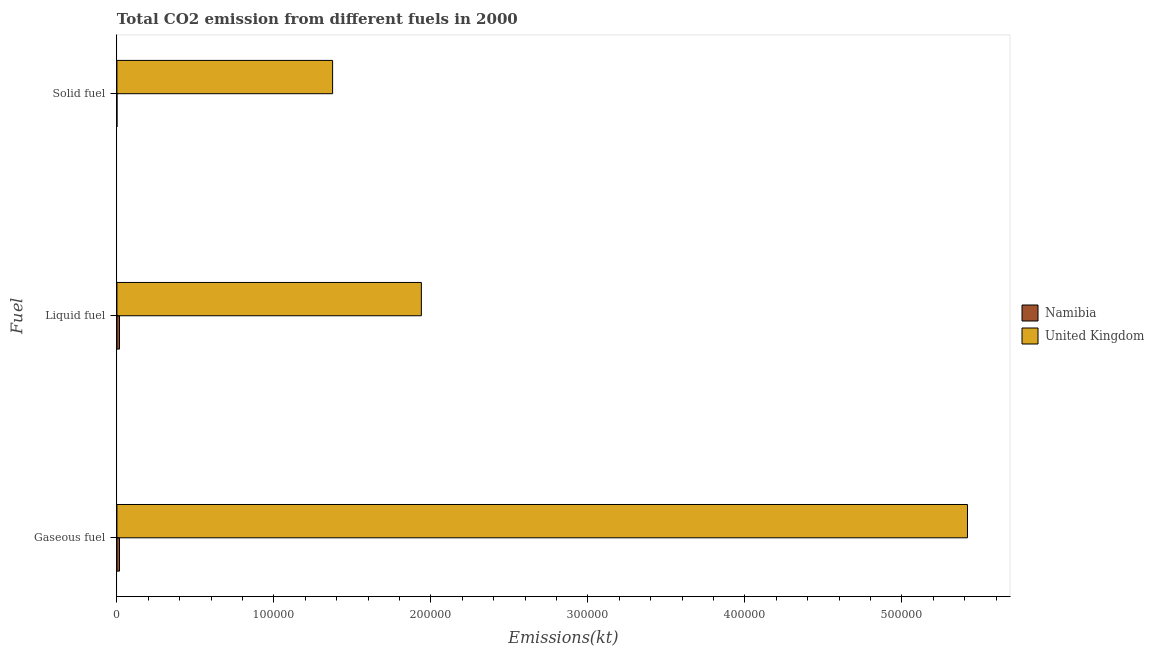How many groups of bars are there?
Your answer should be compact. 3. Are the number of bars on each tick of the Y-axis equal?
Provide a short and direct response. Yes. What is the label of the 2nd group of bars from the top?
Keep it short and to the point. Liquid fuel. What is the amount of co2 emissions from solid fuel in United Kingdom?
Your response must be concise. 1.37e+05. Across all countries, what is the maximum amount of co2 emissions from solid fuel?
Offer a terse response. 1.37e+05. Across all countries, what is the minimum amount of co2 emissions from solid fuel?
Make the answer very short. 7.33. In which country was the amount of co2 emissions from gaseous fuel maximum?
Offer a terse response. United Kingdom. In which country was the amount of co2 emissions from solid fuel minimum?
Provide a succinct answer. Namibia. What is the total amount of co2 emissions from gaseous fuel in the graph?
Ensure brevity in your answer.  5.43e+05. What is the difference between the amount of co2 emissions from solid fuel in United Kingdom and that in Namibia?
Provide a succinct answer. 1.37e+05. What is the difference between the amount of co2 emissions from gaseous fuel in United Kingdom and the amount of co2 emissions from liquid fuel in Namibia?
Provide a succinct answer. 5.40e+05. What is the average amount of co2 emissions from gaseous fuel per country?
Keep it short and to the point. 2.72e+05. What is the difference between the amount of co2 emissions from gaseous fuel and amount of co2 emissions from liquid fuel in United Kingdom?
Offer a terse response. 3.48e+05. What is the ratio of the amount of co2 emissions from solid fuel in Namibia to that in United Kingdom?
Your answer should be compact. 5.337888331376108e-5. Is the difference between the amount of co2 emissions from gaseous fuel in United Kingdom and Namibia greater than the difference between the amount of co2 emissions from solid fuel in United Kingdom and Namibia?
Your answer should be compact. Yes. What is the difference between the highest and the second highest amount of co2 emissions from gaseous fuel?
Offer a very short reply. 5.40e+05. What is the difference between the highest and the lowest amount of co2 emissions from gaseous fuel?
Provide a succinct answer. 5.40e+05. What does the 2nd bar from the top in Gaseous fuel represents?
Offer a very short reply. Namibia. What does the 1st bar from the bottom in Gaseous fuel represents?
Offer a terse response. Namibia. Is it the case that in every country, the sum of the amount of co2 emissions from gaseous fuel and amount of co2 emissions from liquid fuel is greater than the amount of co2 emissions from solid fuel?
Give a very brief answer. Yes. Are the values on the major ticks of X-axis written in scientific E-notation?
Your response must be concise. No. Does the graph contain any zero values?
Make the answer very short. No. Does the graph contain grids?
Provide a succinct answer. No. What is the title of the graph?
Provide a succinct answer. Total CO2 emission from different fuels in 2000. Does "OECD members" appear as one of the legend labels in the graph?
Give a very brief answer. No. What is the label or title of the X-axis?
Your answer should be compact. Emissions(kt). What is the label or title of the Y-axis?
Provide a succinct answer. Fuel. What is the Emissions(kt) of Namibia in Gaseous fuel?
Offer a terse response. 1642.82. What is the Emissions(kt) of United Kingdom in Gaseous fuel?
Provide a short and direct response. 5.42e+05. What is the Emissions(kt) in Namibia in Liquid fuel?
Provide a short and direct response. 1631.82. What is the Emissions(kt) of United Kingdom in Liquid fuel?
Your answer should be very brief. 1.94e+05. What is the Emissions(kt) of Namibia in Solid fuel?
Offer a terse response. 7.33. What is the Emissions(kt) in United Kingdom in Solid fuel?
Make the answer very short. 1.37e+05. Across all Fuel, what is the maximum Emissions(kt) of Namibia?
Ensure brevity in your answer.  1642.82. Across all Fuel, what is the maximum Emissions(kt) in United Kingdom?
Offer a very short reply. 5.42e+05. Across all Fuel, what is the minimum Emissions(kt) of Namibia?
Keep it short and to the point. 7.33. Across all Fuel, what is the minimum Emissions(kt) in United Kingdom?
Offer a very short reply. 1.37e+05. What is the total Emissions(kt) in Namibia in the graph?
Offer a very short reply. 3281.97. What is the total Emissions(kt) of United Kingdom in the graph?
Your response must be concise. 8.73e+05. What is the difference between the Emissions(kt) in Namibia in Gaseous fuel and that in Liquid fuel?
Give a very brief answer. 11. What is the difference between the Emissions(kt) in United Kingdom in Gaseous fuel and that in Liquid fuel?
Your response must be concise. 3.48e+05. What is the difference between the Emissions(kt) of Namibia in Gaseous fuel and that in Solid fuel?
Your answer should be very brief. 1635.48. What is the difference between the Emissions(kt) of United Kingdom in Gaseous fuel and that in Solid fuel?
Your answer should be very brief. 4.04e+05. What is the difference between the Emissions(kt) in Namibia in Liquid fuel and that in Solid fuel?
Provide a short and direct response. 1624.48. What is the difference between the Emissions(kt) in United Kingdom in Liquid fuel and that in Solid fuel?
Provide a succinct answer. 5.65e+04. What is the difference between the Emissions(kt) in Namibia in Gaseous fuel and the Emissions(kt) in United Kingdom in Liquid fuel?
Provide a short and direct response. -1.92e+05. What is the difference between the Emissions(kt) in Namibia in Gaseous fuel and the Emissions(kt) in United Kingdom in Solid fuel?
Your response must be concise. -1.36e+05. What is the difference between the Emissions(kt) of Namibia in Liquid fuel and the Emissions(kt) of United Kingdom in Solid fuel?
Your response must be concise. -1.36e+05. What is the average Emissions(kt) of Namibia per Fuel?
Give a very brief answer. 1093.99. What is the average Emissions(kt) of United Kingdom per Fuel?
Make the answer very short. 2.91e+05. What is the difference between the Emissions(kt) of Namibia and Emissions(kt) of United Kingdom in Gaseous fuel?
Provide a succinct answer. -5.40e+05. What is the difference between the Emissions(kt) in Namibia and Emissions(kt) in United Kingdom in Liquid fuel?
Keep it short and to the point. -1.92e+05. What is the difference between the Emissions(kt) of Namibia and Emissions(kt) of United Kingdom in Solid fuel?
Keep it short and to the point. -1.37e+05. What is the ratio of the Emissions(kt) in United Kingdom in Gaseous fuel to that in Liquid fuel?
Your response must be concise. 2.79. What is the ratio of the Emissions(kt) in Namibia in Gaseous fuel to that in Solid fuel?
Give a very brief answer. 224. What is the ratio of the Emissions(kt) in United Kingdom in Gaseous fuel to that in Solid fuel?
Keep it short and to the point. 3.94. What is the ratio of the Emissions(kt) of Namibia in Liquid fuel to that in Solid fuel?
Your answer should be very brief. 222.5. What is the ratio of the Emissions(kt) of United Kingdom in Liquid fuel to that in Solid fuel?
Your response must be concise. 1.41. What is the difference between the highest and the second highest Emissions(kt) in Namibia?
Give a very brief answer. 11. What is the difference between the highest and the second highest Emissions(kt) of United Kingdom?
Keep it short and to the point. 3.48e+05. What is the difference between the highest and the lowest Emissions(kt) in Namibia?
Ensure brevity in your answer.  1635.48. What is the difference between the highest and the lowest Emissions(kt) in United Kingdom?
Ensure brevity in your answer.  4.04e+05. 